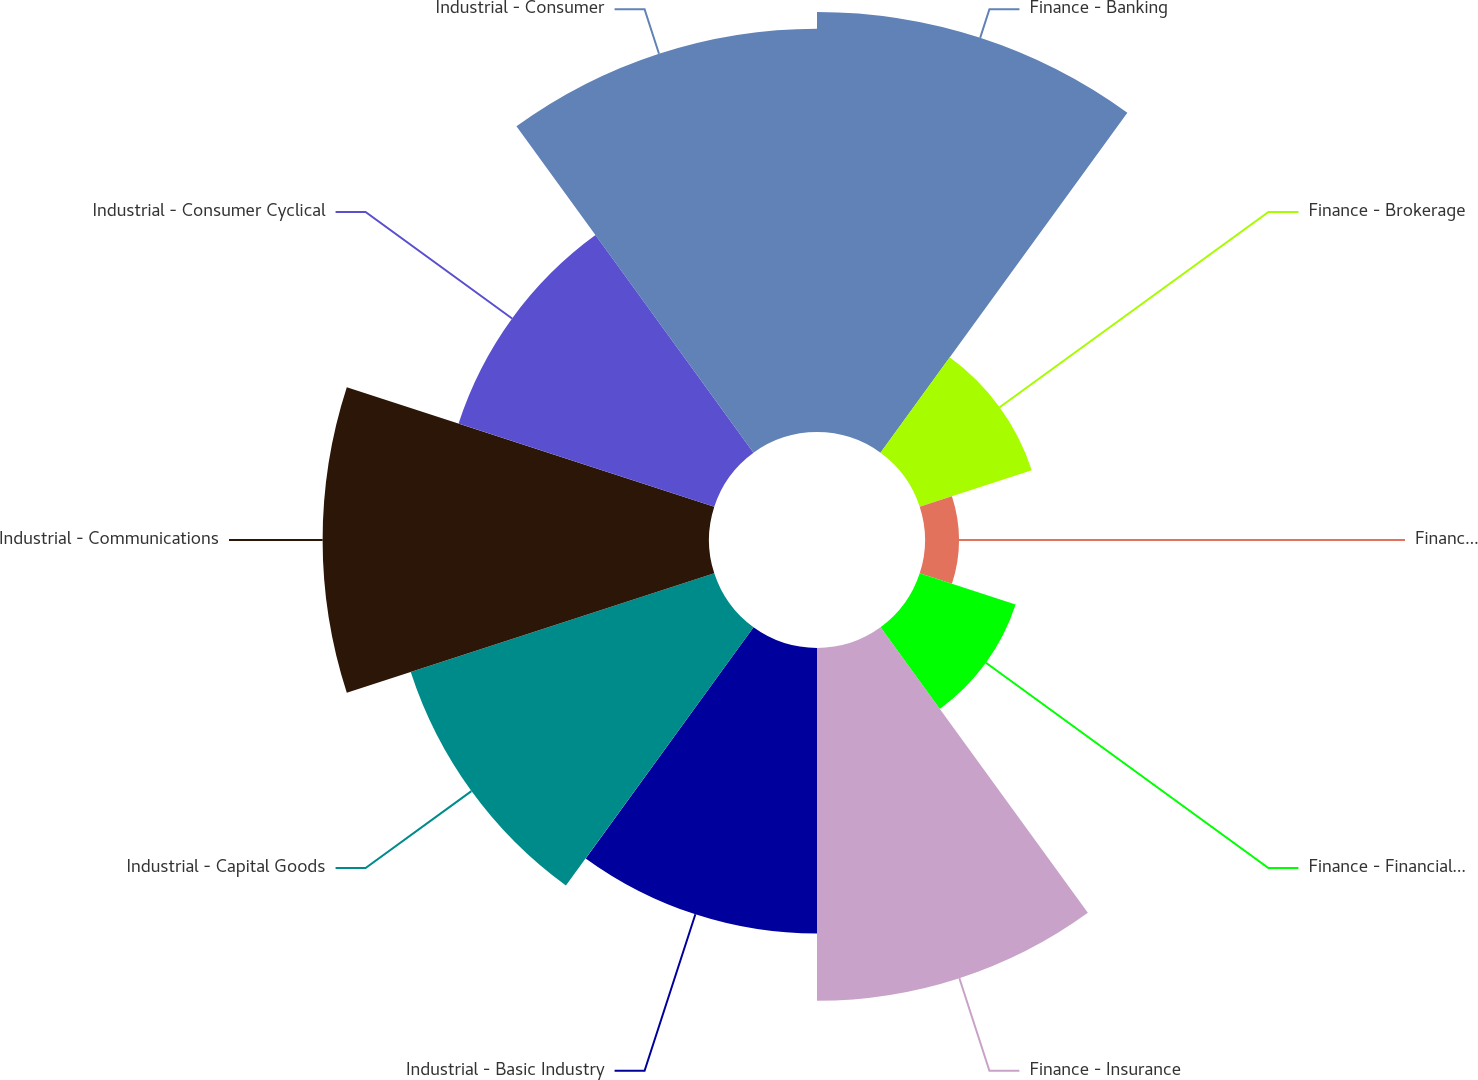<chart> <loc_0><loc_0><loc_500><loc_500><pie_chart><fcel>Finance - Banking<fcel>Finance - Brokerage<fcel>Finance - Finance Companies<fcel>Finance - Financial Other<fcel>Finance - Insurance<fcel>Industrial - Basic Industry<fcel>Industrial - Capital Goods<fcel>Industrial - Communications<fcel>Industrial - Consumer Cyclical<fcel>Industrial - Consumer<nl><fcel>15.62%<fcel>4.38%<fcel>1.26%<fcel>3.75%<fcel>13.12%<fcel>10.62%<fcel>11.87%<fcel>14.37%<fcel>10.0%<fcel>15.0%<nl></chart> 